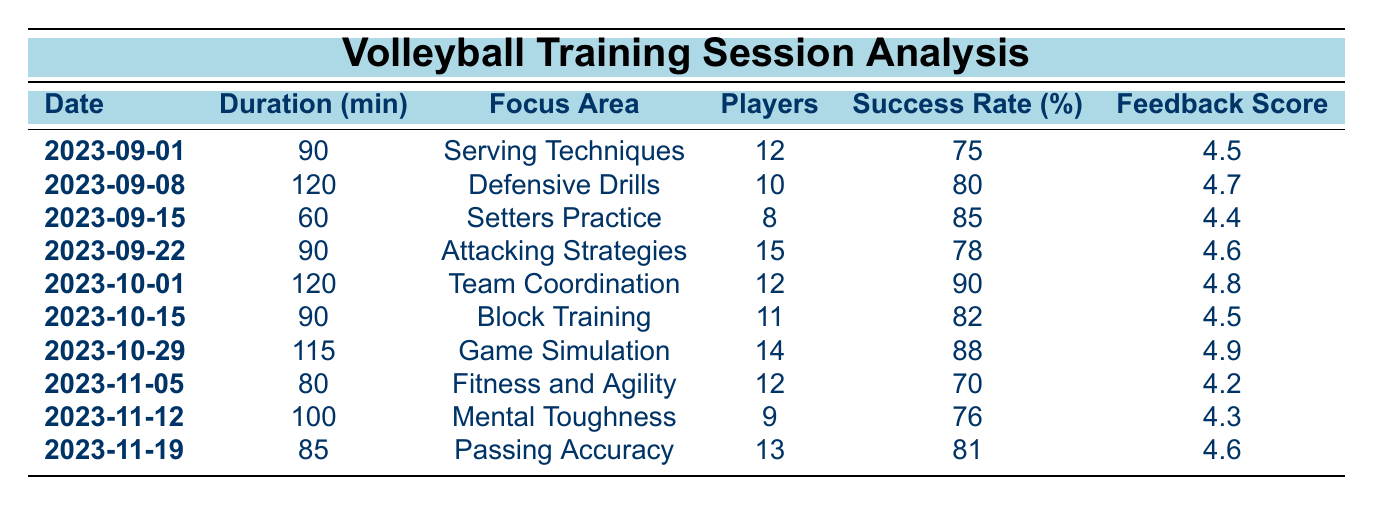What was the focus area of the training session on 2023-10-01? According to the table, the training session on 2023-10-01 focuses on "Team Coordination."
Answer: Team Coordination How many players participated in the session focused on Passing Accuracy? The table indicates that 13 players participated in the session focused on Passing Accuracy on 2023-11-19.
Answer: 13 What is the average success rate of all the training sessions? To calculate the average success rate, sum the success rates (75 + 80 + 85 + 78 + 90 + 82 + 88 + 70 + 76 + 81 = 814) and divide by the number of sessions (10). Thus, the average success rate is 814/10 = 81.4.
Answer: 81.4 Did any session have a feedback score of 4.9? Yes, the session on 2023-10-29 had a feedback score of 4.9.
Answer: Yes Which session had the longest duration and what was its focus area? The session with the longest duration was on 2023-09-08, lasting 120 minutes, with a focus area of "Defensive Drills."
Answer: Defensive Drills What is the total duration of all training sessions combined? To find the total duration, sum up all the durations: (90 + 120 + 60 + 90 + 120 + 90 + 115 + 80 + 100 + 85 = 1050) minutes.
Answer: 1050 Was the success rate for "Fitness and Agility" higher than the average success rate? The success rate for "Fitness and Agility" is 70, which is lower than the average success rate of 81.4 calculated previously.
Answer: No How many sessions had a feedback score of 4.5 or higher? Reviewing the feedback scores in the table, there are 7 sessions with scores of 4.5 or higher: (4.5, 4.7, 4.4, 4.6, 4.8, 4.5, 4.9, 4.2, 4.3, 4.6). Counting these gives us 6 sessions.
Answer: 6 What is the success rate difference between the "Block Training" session and the "Setters Practice" session? The success rate for "Block Training" (82) minus the success rate for "Setters Practice" (85) gives a difference of -3.
Answer: -3 Which focus area had the highest success rate? The training session on 2023-10-01, focused on "Team Coordination," had the highest success rate of 90.
Answer: Team Coordination 